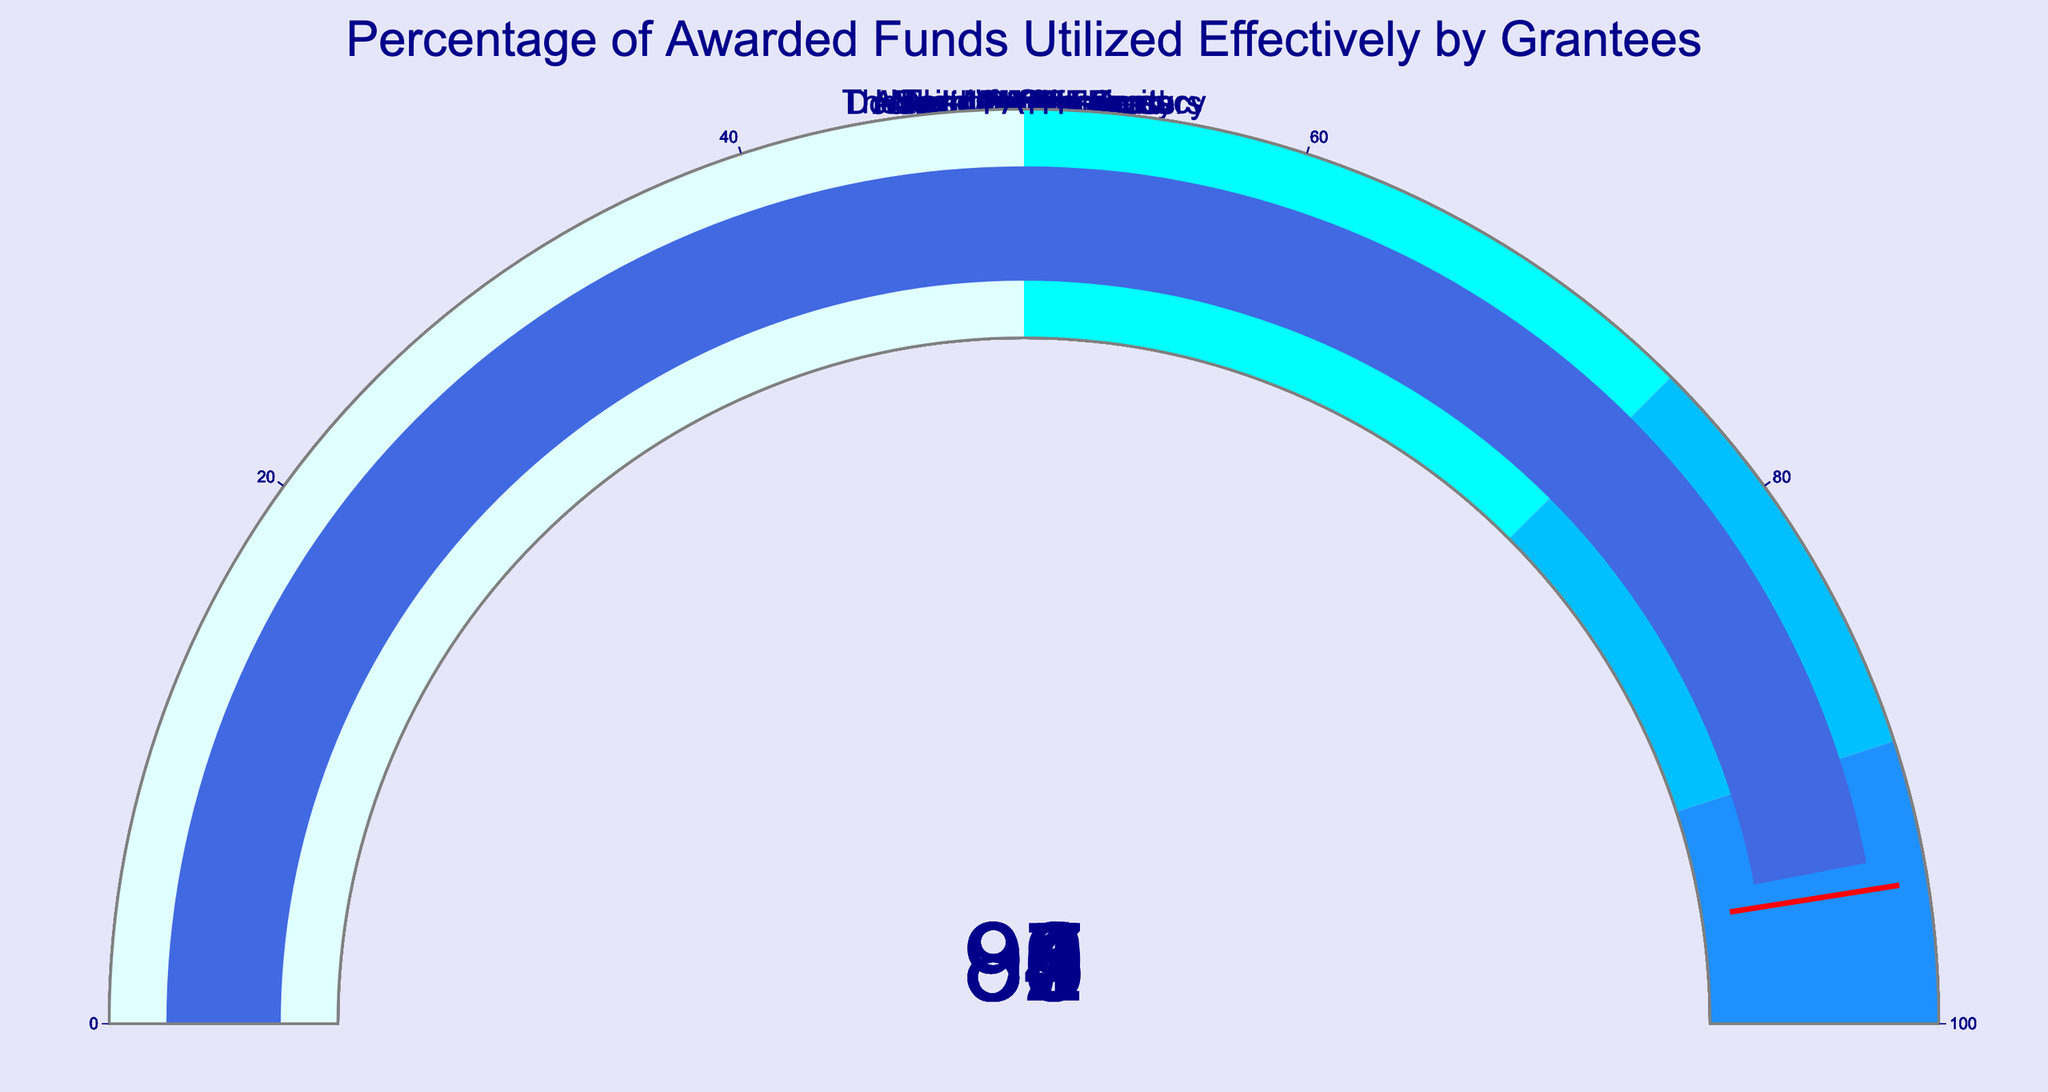What is the title of the figure? The title is often displayed prominently at the top of the figure. In this case, it reads "Percentage of Awarded Funds Utilized Effectively by Grantees."
Answer: Percentage of Awarded Funds Utilized Effectively by Grantees Which organization has the highest percentage of awarded funds utilized? By examining the gauges, the one with the highest percentage will be represented by a needle closest to 100. The "Doctors Without Borders" gauge shows 95%, the highest in the figure.
Answer: Doctors Without Borders What color represents the range for percentages between 90 and 100? The color range for different percentage intervals can be observed on each gauge. The range for 90 to 100% is indicated in "dodgerblue."
Answer: Dodgerblue What is the average percentage of awarded funds utilized across all organizations? Sum the percentages of all organizations and divide by the number of organizations: (92 + 88 + 85 + 95 + 91 + 87 + 93 + 89 + 86 + 94) / 10 = 900 / 10.
Answer: 90 Which two organizations have the closest percentage values? Looking for the smallest difference between pairs of percentages in the data, the smallest difference is between "Save the Children (89%)" and "Habitat for Humanity (88%)."
Answer: Save the Children and Habitat for Humanity How many organizations have a utilization percentage of 90% or higher? Count the gauges where the needle points to 90 or above: "American Red Cross (92%)," "Doctors Without Borders (95%)," "UNICEF (91%)," "Feeding America (93%)," "PATH (94%)." That's five organizations.
Answer: 5 What percentage threshold is represented with a red line? Each gauge has a threshold marked with a red line at a certain value. This red line intersects at 95%.
Answer: 95% Which organization utilizes the least percentage of awarded funds? The gauge with the lowest percentage will show the needle closest to 0. "World Wildlife Fund" has the lowest utilization at 85%.
Answer: World Wildlife Fund What is the median percentage of awarded funds utilized by the organizations? To find the median, arrange the percentages in ascending order and find the middle value. In this case, the ordered values are 85, 86, 87, 88, 89, 91, 92, 93, 94, 95. With ten numbers, the median is the average of the 5th and 6th numbers: (89 + 91) / 2.
Answer: 90 